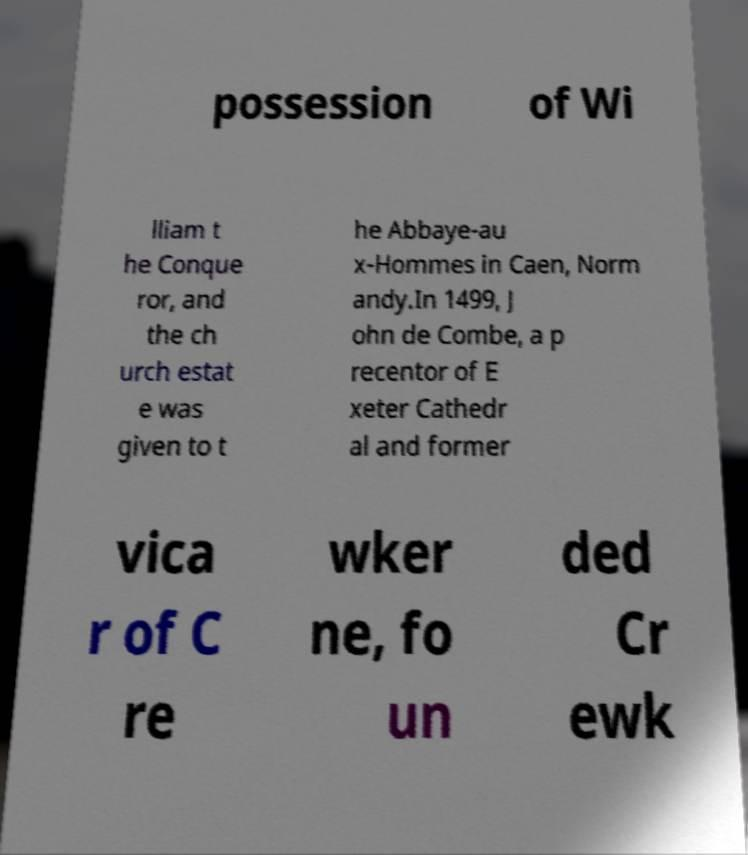Can you accurately transcribe the text from the provided image for me? possession of Wi lliam t he Conque ror, and the ch urch estat e was given to t he Abbaye-au x-Hommes in Caen, Norm andy.In 1499, J ohn de Combe, a p recentor of E xeter Cathedr al and former vica r of C re wker ne, fo un ded Cr ewk 